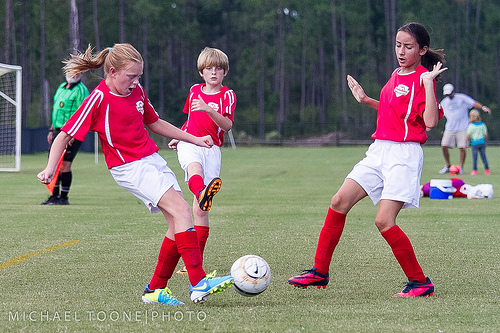<image>
Is there a tree behind the man? Yes. From this viewpoint, the tree is positioned behind the man, with the man partially or fully occluding the tree. 